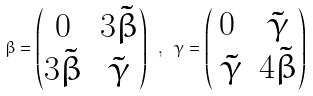Convert formula to latex. <formula><loc_0><loc_0><loc_500><loc_500>\beta = \begin{pmatrix} 0 & 3 \tilde { \beta } \\ 3 \tilde { \beta } & \tilde { \gamma } \end{pmatrix} \ , \ \gamma = \begin{pmatrix} 0 & \tilde { \gamma } \\ \ \tilde { \gamma } & 4 \tilde { \beta } \end{pmatrix}</formula> 